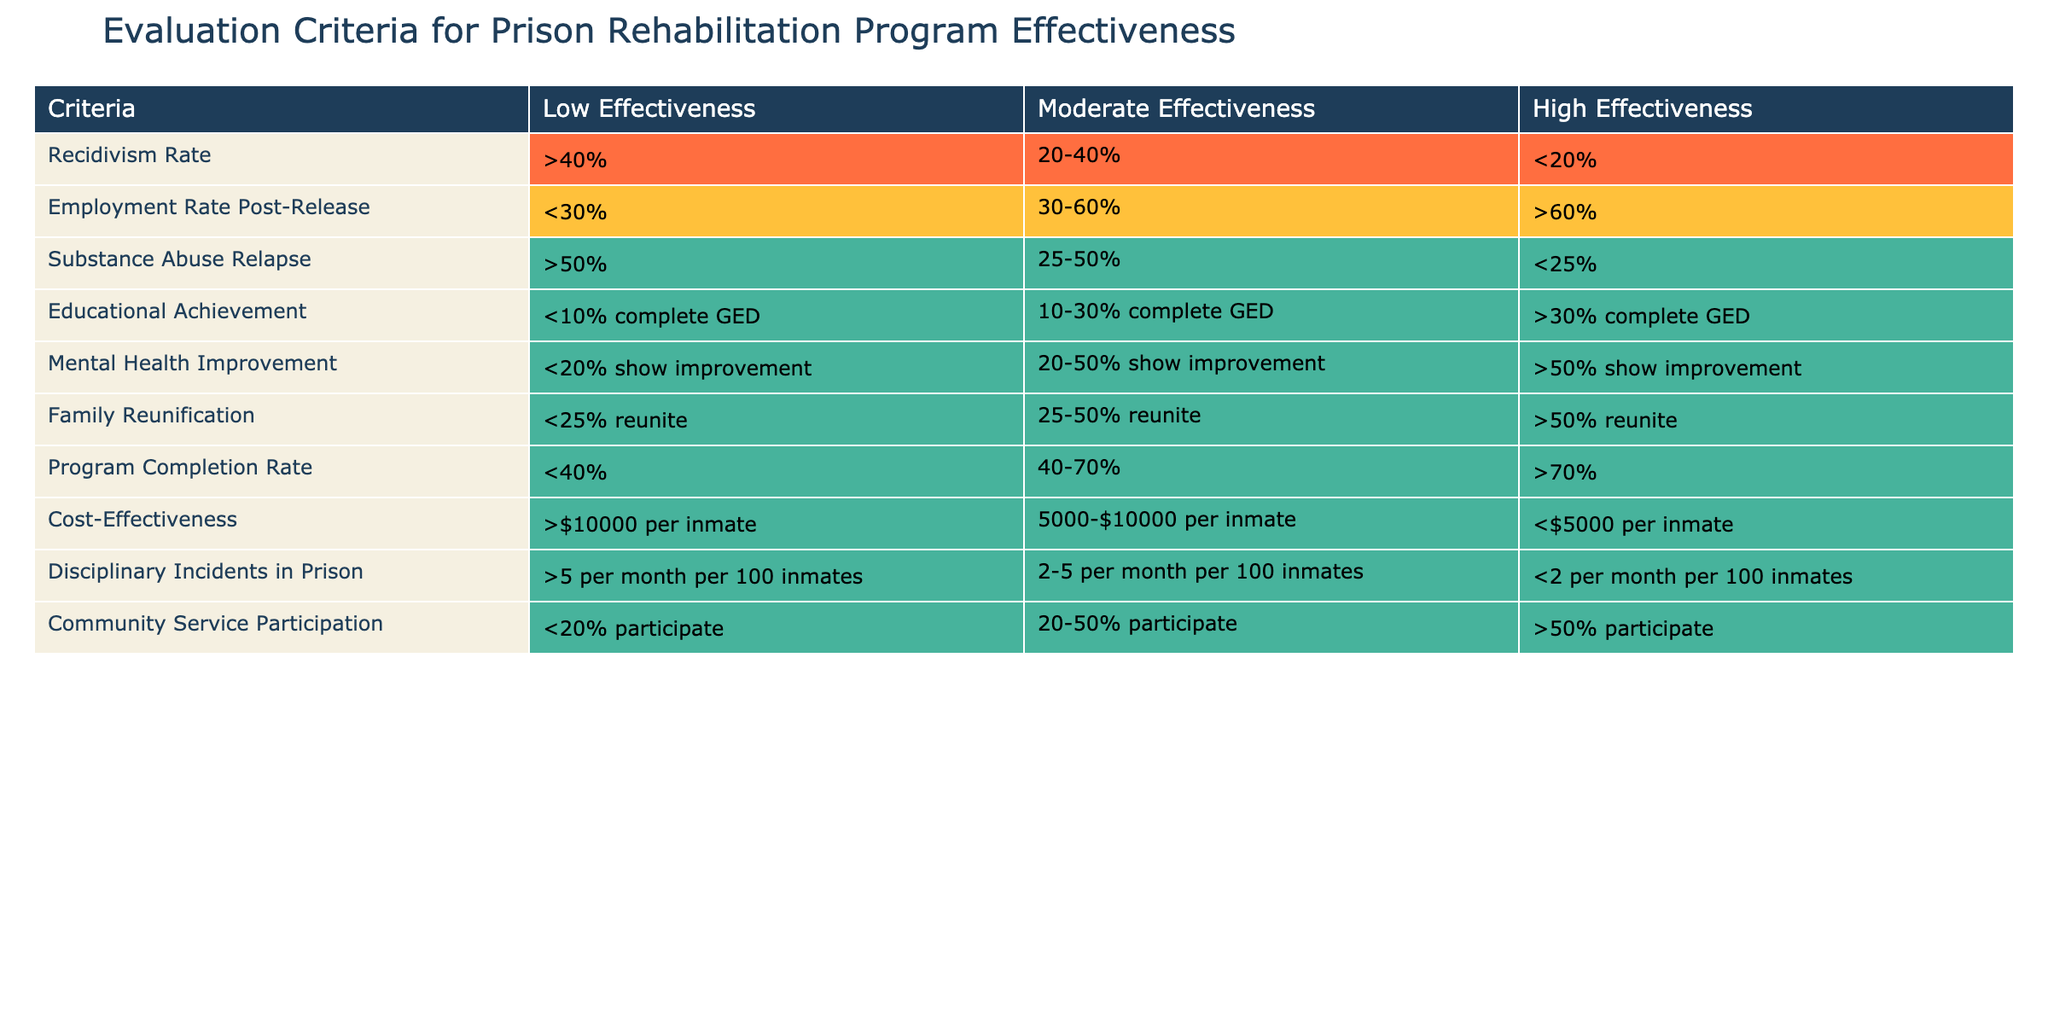What is the recidivism rate that indicates high effectiveness of a prison rehabilitation program? According to the table, a recidivism rate of less than 20% is categorized as high effectiveness.
Answer: Less than 20% What percentage of employment rate post-release signifies low effectiveness? The table specifies that an employment rate post-release of less than 30% indicates low effectiveness.
Answer: Less than 30% Is a substance abuse relapse rate of 30% considered moderate or high effectiveness? The table shows that a substance abuse relapse rate of 30% falls within the range of 25-50%, which is categorized as moderate effectiveness.
Answer: Moderate effectiveness What is the average cost-effectiveness score if we consider the ranges: 3 program categories at $10,000, 2 at $7,500, and 5 at $4,000? The total cost for 10 programs would be (3 * 10000) + (2 * 7500) + (5 * 4000) = 30000 + 15000 + 20000 = 65000. Dividing by 10 gives an average cost of 6500 per inmate, which is considered high effectiveness.
Answer: $6,500 Does a family reunification rate of greater than 50% contribute to high effectiveness? Yes, based on the table, a family reunification rate of greater than 50% is listed under the high effectiveness category.
Answer: Yes What is the relationship between educational achievement and recidivism rate effectiveness? The table indicates that educational achievement of over 30% complete GED correlates with high effectiveness, whereas a recidivism rate of less than 20% also correlates with high effectiveness. Therefore, higher educational achievements are likely associated with lower recidivism rates, suggesting a positive relationship.
Answer: Positive relationship Are there more criteria indicating low effectiveness than high effectiveness? Yes, reviewing the table shows there are five criteria under low effectiveness (recidivism, employment rate, substance abuse, educational achievement, and program completion rate) compared to three under high effectiveness.
Answer: Yes How many disciplinary incidents per month per 100 inmates are acceptable for high effectiveness? The table states that having less than 2 disciplinary incidents per month per 100 inmates meets the criteria for high effectiveness.
Answer: Less than 2 incidents 